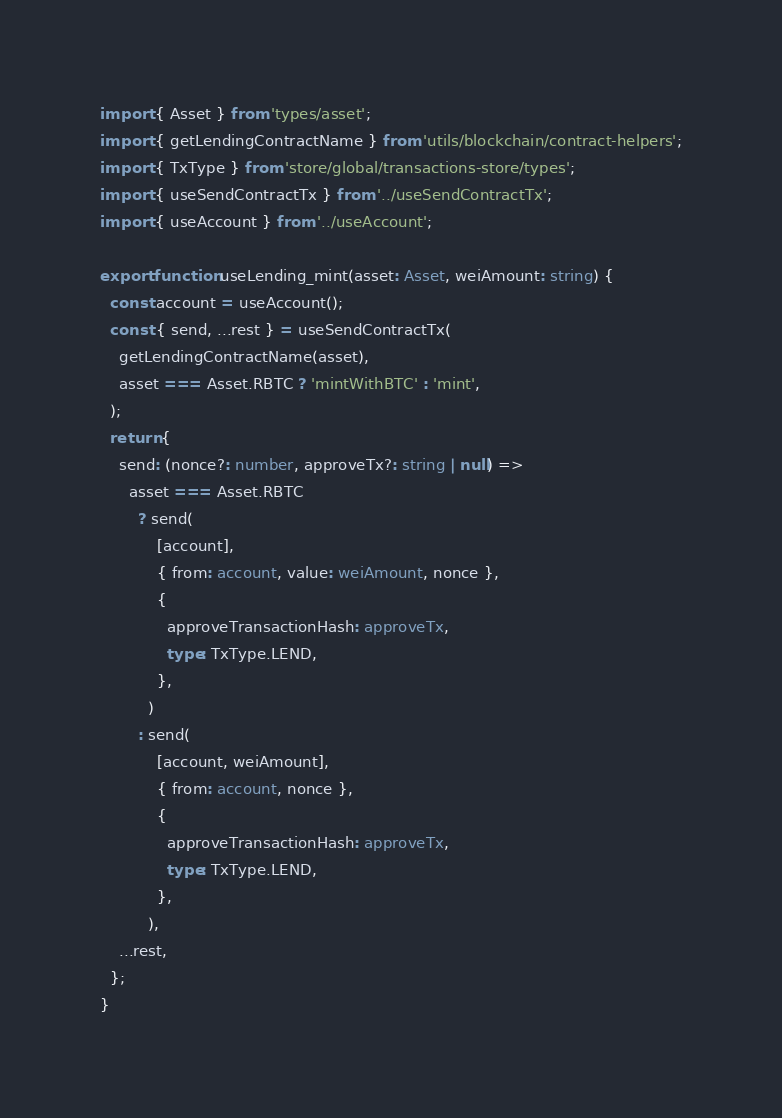Convert code to text. <code><loc_0><loc_0><loc_500><loc_500><_TypeScript_>import { Asset } from 'types/asset';
import { getLendingContractName } from 'utils/blockchain/contract-helpers';
import { TxType } from 'store/global/transactions-store/types';
import { useSendContractTx } from '../useSendContractTx';
import { useAccount } from '../useAccount';

export function useLending_mint(asset: Asset, weiAmount: string) {
  const account = useAccount();
  const { send, ...rest } = useSendContractTx(
    getLendingContractName(asset),
    asset === Asset.RBTC ? 'mintWithBTC' : 'mint',
  );
  return {
    send: (nonce?: number, approveTx?: string | null) =>
      asset === Asset.RBTC
        ? send(
            [account],
            { from: account, value: weiAmount, nonce },
            {
              approveTransactionHash: approveTx,
              type: TxType.LEND,
            },
          )
        : send(
            [account, weiAmount],
            { from: account, nonce },
            {
              approveTransactionHash: approveTx,
              type: TxType.LEND,
            },
          ),
    ...rest,
  };
}
</code> 